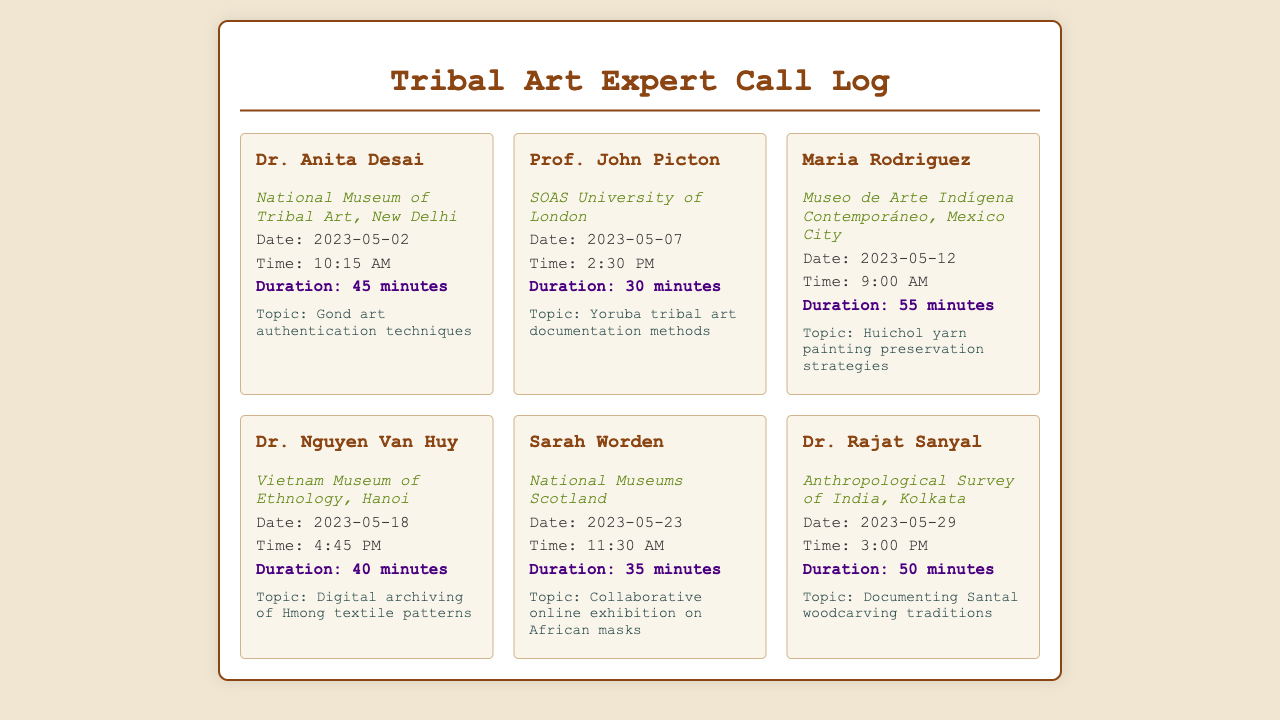What is the name of the first expert? The first expert listed in the document is Dr. Anita Desai.
Answer: Dr. Anita Desai What organization is Maria Rodriguez associated with? Maria Rodriguez is associated with the Museo de Arte Indígena Contemporáneo.
Answer: Museo de Arte Indígena Contemporáneo How long was the call with Dr. Rajat Sanyal? The duration of the call with Dr. Rajat Sanyal was 50 minutes.
Answer: 50 minutes What topic did Prof. John Picton discuss? Prof. John Picton discussed Yoruba tribal art documentation methods.
Answer: Yoruba tribal art documentation methods On what date did Sarah Worden's call take place? Sarah Worden's call took place on May 23, 2023.
Answer: May 23, 2023 Which expert focused on digital archiving? Dr. Nguyen Van Huy focused on digital archiving of Hmong textile patterns.
Answer: Dr. Nguyen Van Huy How many calls are documented in total? There are a total of six call entries documented.
Answer: Six What was the time of the call with Dr. Anita Desai? The call with Dr. Anita Desai was at 10:15 AM.
Answer: 10:15 AM 